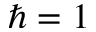<formula> <loc_0><loc_0><loc_500><loc_500>\hbar { = } 1</formula> 